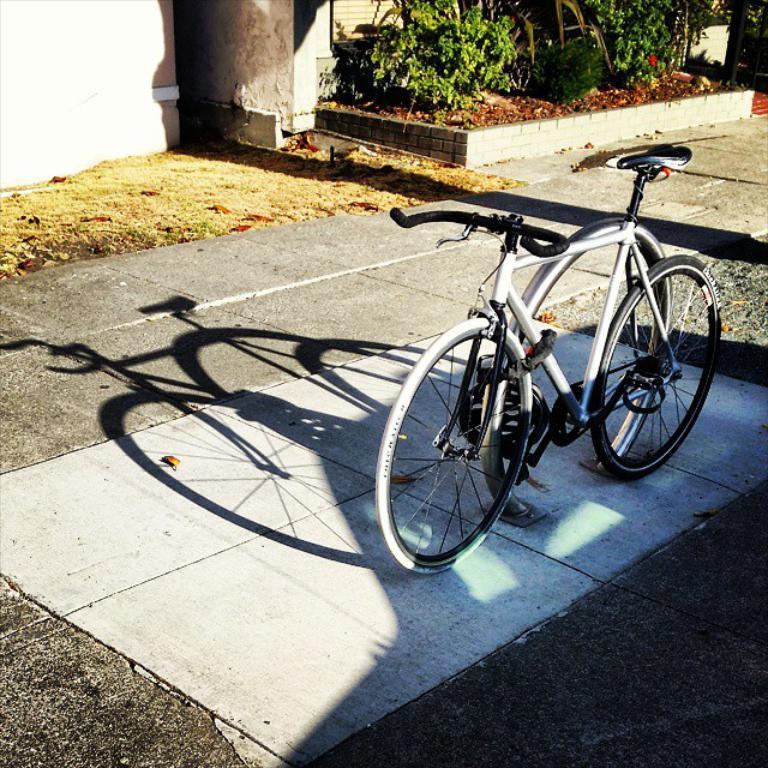What is the main subject in the center of the image? There is a bicycle sculpture in the center of the image. What can be seen in the background of the image? There are plants and a wall in the background of the image. Can you describe the shadow in the image? There is a shadow on the road at the bottom of the image. What type of dinner is being served at the event in the image? There is no event or dinner present in the image; it features a bicycle sculpture, plants, a wall, and a shadow. 